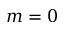Convert formula to latex. <formula><loc_0><loc_0><loc_500><loc_500>m = 0</formula> 